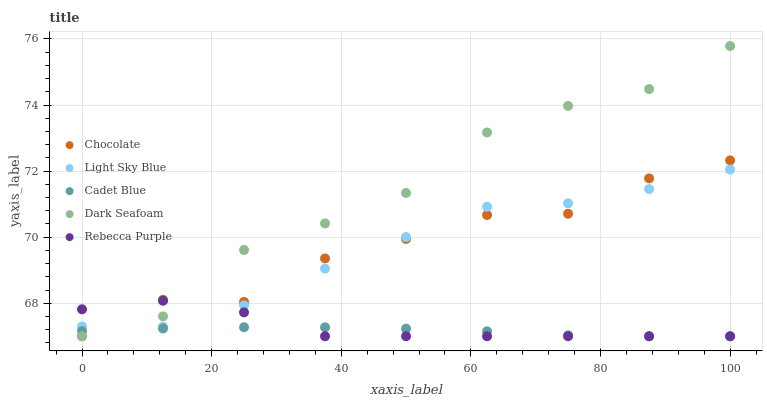Does Cadet Blue have the minimum area under the curve?
Answer yes or no. Yes. Does Dark Seafoam have the maximum area under the curve?
Answer yes or no. Yes. Does Light Sky Blue have the minimum area under the curve?
Answer yes or no. No. Does Light Sky Blue have the maximum area under the curve?
Answer yes or no. No. Is Cadet Blue the smoothest?
Answer yes or no. Yes. Is Dark Seafoam the roughest?
Answer yes or no. Yes. Is Light Sky Blue the smoothest?
Answer yes or no. No. Is Light Sky Blue the roughest?
Answer yes or no. No. Does Cadet Blue have the lowest value?
Answer yes or no. Yes. Does Light Sky Blue have the lowest value?
Answer yes or no. No. Does Dark Seafoam have the highest value?
Answer yes or no. Yes. Does Light Sky Blue have the highest value?
Answer yes or no. No. Is Cadet Blue less than Light Sky Blue?
Answer yes or no. Yes. Is Light Sky Blue greater than Cadet Blue?
Answer yes or no. Yes. Does Light Sky Blue intersect Chocolate?
Answer yes or no. Yes. Is Light Sky Blue less than Chocolate?
Answer yes or no. No. Is Light Sky Blue greater than Chocolate?
Answer yes or no. No. Does Cadet Blue intersect Light Sky Blue?
Answer yes or no. No. 